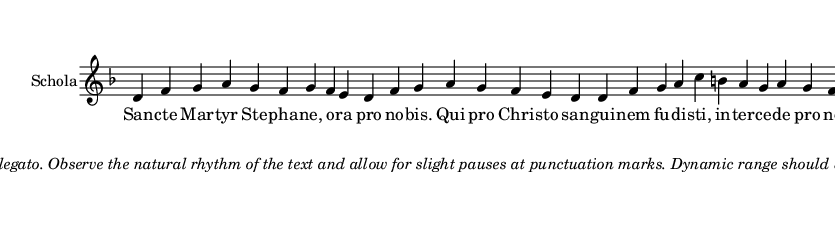What is the key signature of this music? The key signature is D minor, indicated by the presence of one flat (B flat) in the key signature area.
Answer: D minor What is the time signature of this music? The time signature is not explicitly indicated, but the rhythm suggests a simple 4/4 meter based on the melody and lyrics.
Answer: 4/4 How many measures are in the melody? By counting the note groups and spaces in the melody section, there are a total of 8 measures.
Answer: 8 What is the mood suggested by the performance instructions? The instructions suggest a reverent and prayerful mood, emphasizing smooth legato playing and modest dynamics.
Answer: Reverent Which saint is being celebrated in this chant? The chant celebrates Saint Stephen, as indicated in the lyrics referencing "Sancte Martyr Stephane."
Answer: Saint Stephen What is the overall dynamic range suggested for this piece? The performance instructions recommend a modest dynamic range, focusing on clear diction and pure tone rather than dramatic contrasts.
Answer: Modest What theme is prevalent in the lyrics of this chant? The theme of intercession is prevalent, as the lyrics call for the saint's intercession for the faithful before God.
Answer: Intercession 